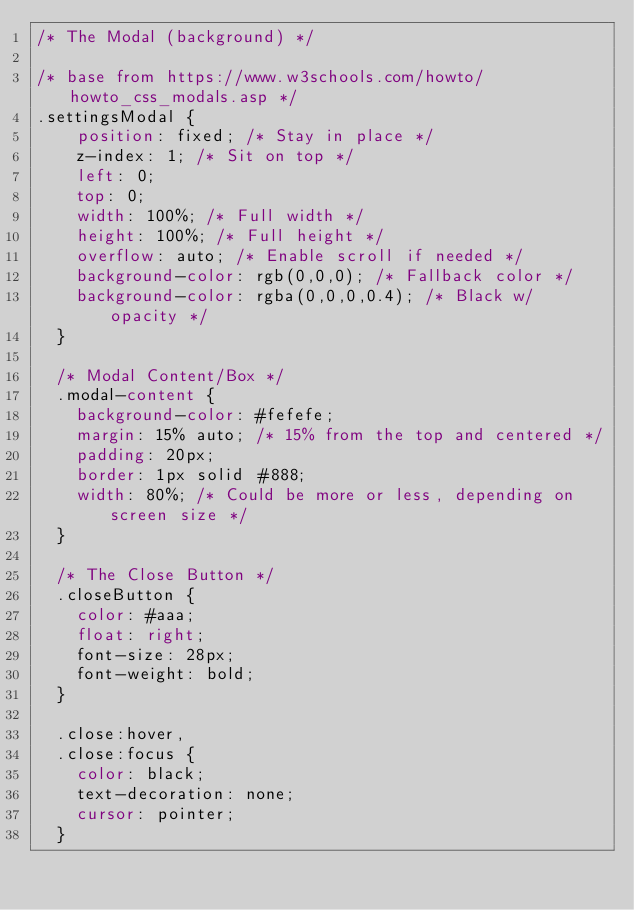Convert code to text. <code><loc_0><loc_0><loc_500><loc_500><_CSS_>/* The Modal (background) */

/* base from https://www.w3schools.com/howto/howto_css_modals.asp */
.settingsModal {
    position: fixed; /* Stay in place */
    z-index: 1; /* Sit on top */
    left: 0;
    top: 0;
    width: 100%; /* Full width */
    height: 100%; /* Full height */
    overflow: auto; /* Enable scroll if needed */
    background-color: rgb(0,0,0); /* Fallback color */
    background-color: rgba(0,0,0,0.4); /* Black w/ opacity */
  }
  
  /* Modal Content/Box */
  .modal-content {
    background-color: #fefefe;
    margin: 15% auto; /* 15% from the top and centered */
    padding: 20px;
    border: 1px solid #888;
    width: 80%; /* Could be more or less, depending on screen size */
  }
  
  /* The Close Button */
  .closeButton {
    color: #aaa;
    float: right;
    font-size: 28px;
    font-weight: bold;
  }
  
  .close:hover,
  .close:focus {
    color: black;
    text-decoration: none;
    cursor: pointer;
  }</code> 